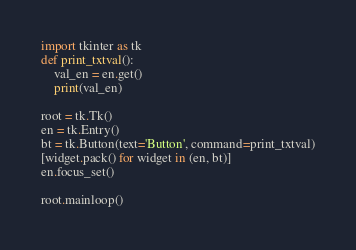<code> <loc_0><loc_0><loc_500><loc_500><_Python_>import tkinter as tk
def print_txtval():
    val_en = en.get()
    print(val_en)

root = tk.Tk()
en = tk.Entry()
bt = tk.Button(text='Button', command=print_txtval)
[widget.pack() for widget in (en, bt)]
en.focus_set()

root.mainloop()</code> 